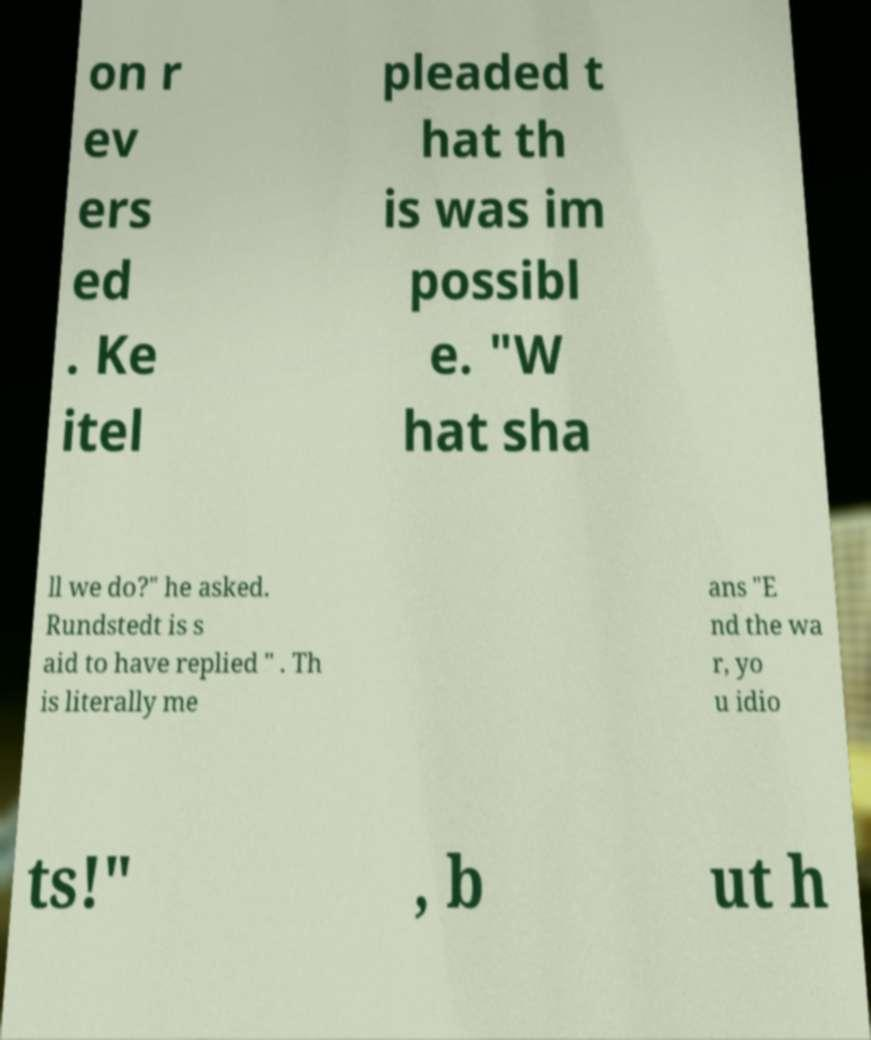For documentation purposes, I need the text within this image transcribed. Could you provide that? on r ev ers ed . Ke itel pleaded t hat th is was im possibl e. "W hat sha ll we do?" he asked. Rundstedt is s aid to have replied " . Th is literally me ans "E nd the wa r, yo u idio ts!" , b ut h 